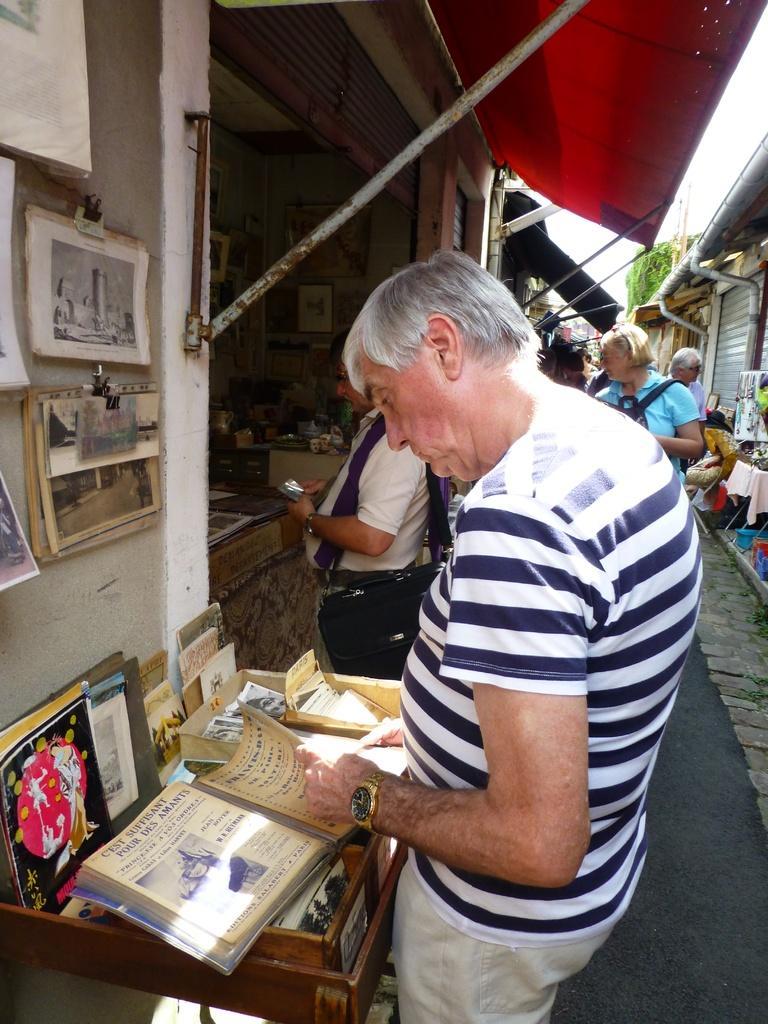How would you summarize this image in a sentence or two? In this picture we can see few persons, table, books, cloth, shutters, and objects. There is a wall. In the background there is sky. 